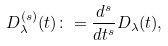<formula> <loc_0><loc_0><loc_500><loc_500>D ^ { ( s ) } _ { \lambda } ( t ) \colon = \frac { d ^ { s } } { d t ^ { s } } D _ { \lambda } ( t ) ,</formula> 